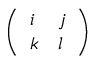<formula> <loc_0><loc_0><loc_500><loc_500>\left ( \begin{array} { l l } { i } & { j } \\ { k } & { l } \end{array} \right )</formula> 